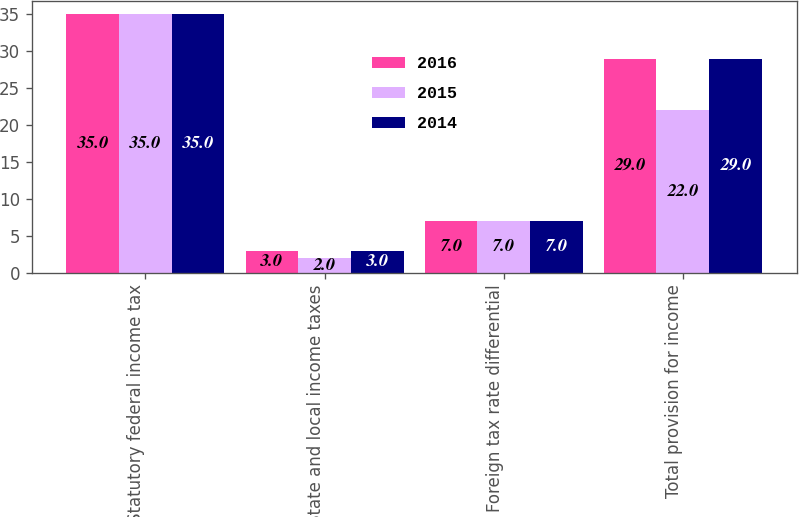Convert chart. <chart><loc_0><loc_0><loc_500><loc_500><stacked_bar_chart><ecel><fcel>Statutory federal income tax<fcel>State and local income taxes<fcel>Foreign tax rate differential<fcel>Total provision for income<nl><fcel>2016<fcel>35<fcel>3<fcel>7<fcel>29<nl><fcel>2015<fcel>35<fcel>2<fcel>7<fcel>22<nl><fcel>2014<fcel>35<fcel>3<fcel>7<fcel>29<nl></chart> 